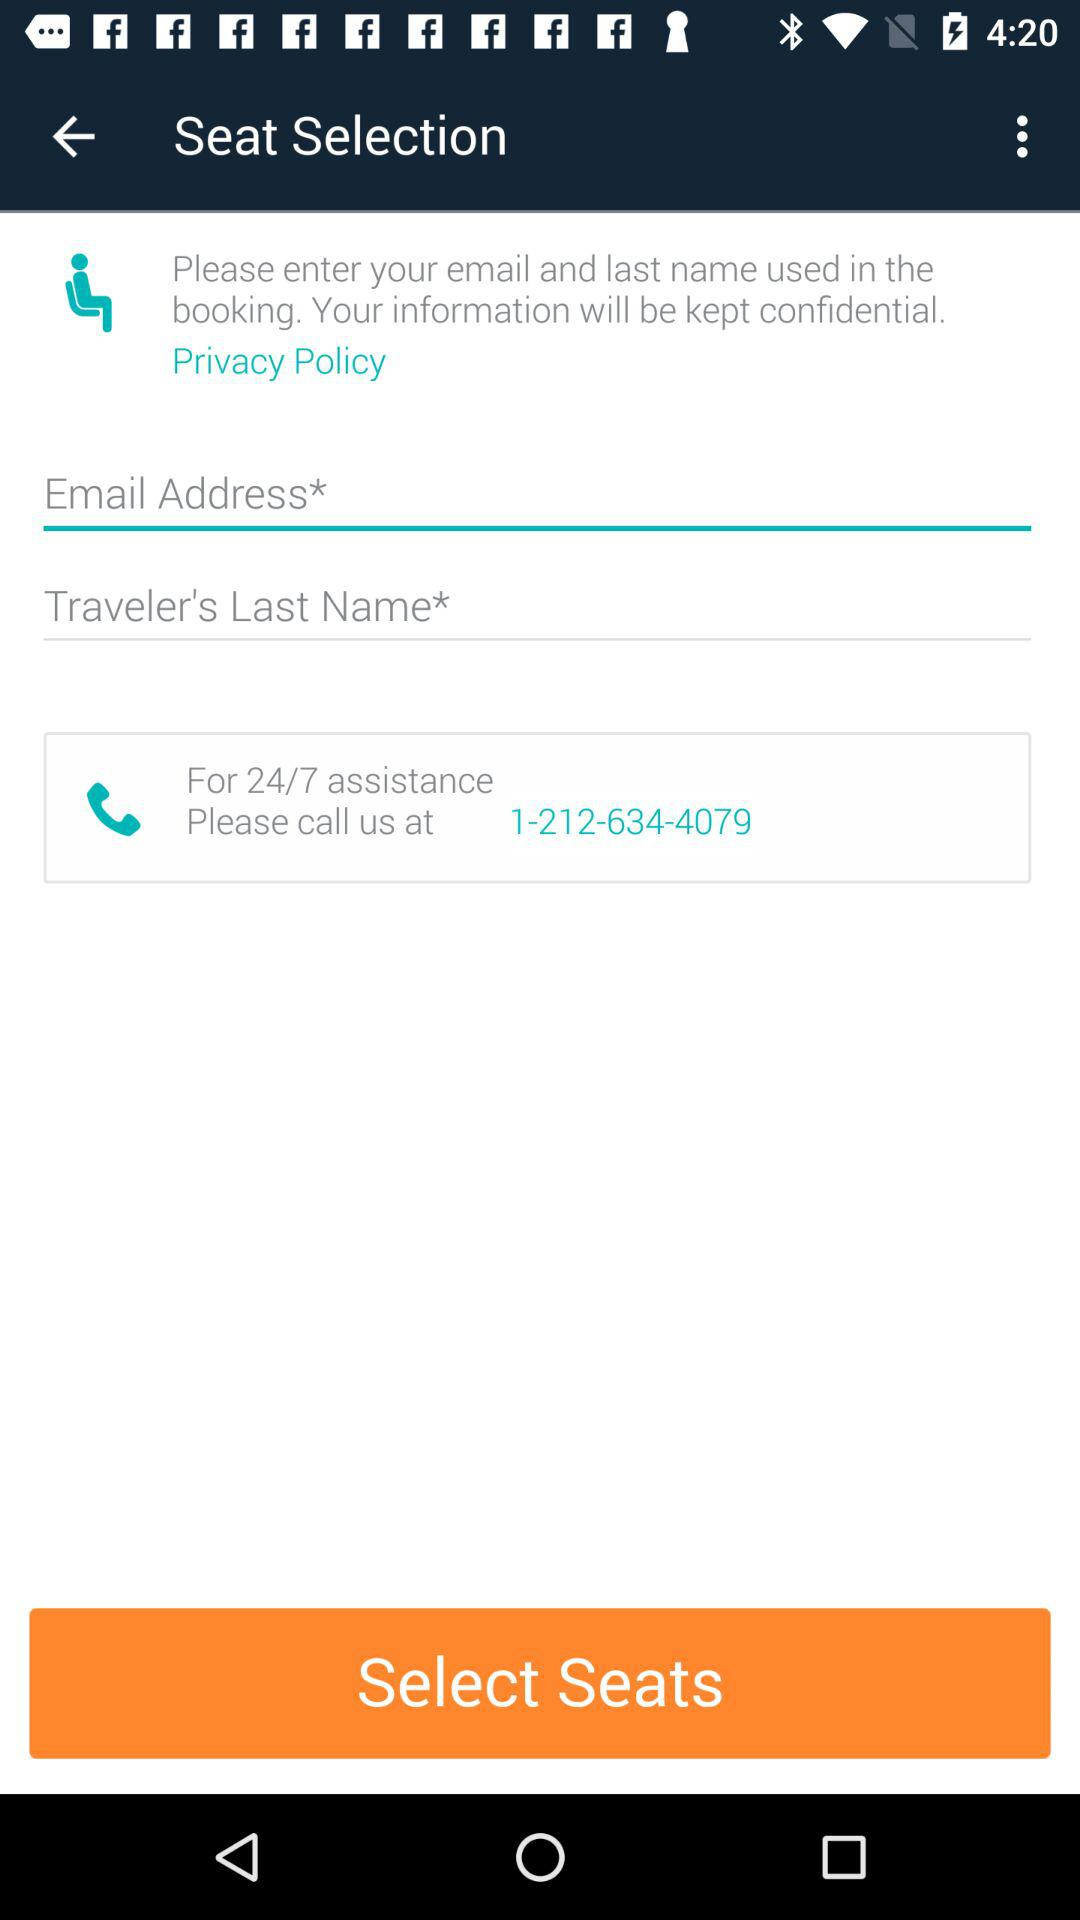What information is considered confidential according to the statement above the text inputs? The statement above the text inputs assures that the email and last name used in the booking are considered confidential information. 